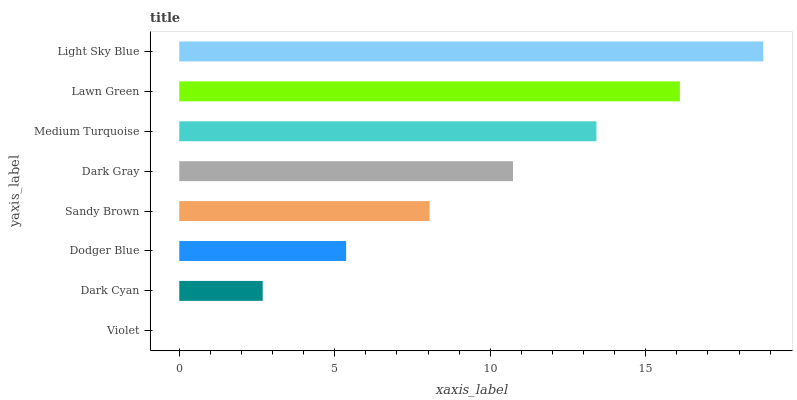Is Violet the minimum?
Answer yes or no. Yes. Is Light Sky Blue the maximum?
Answer yes or no. Yes. Is Dark Cyan the minimum?
Answer yes or no. No. Is Dark Cyan the maximum?
Answer yes or no. No. Is Dark Cyan greater than Violet?
Answer yes or no. Yes. Is Violet less than Dark Cyan?
Answer yes or no. Yes. Is Violet greater than Dark Cyan?
Answer yes or no. No. Is Dark Cyan less than Violet?
Answer yes or no. No. Is Dark Gray the high median?
Answer yes or no. Yes. Is Sandy Brown the low median?
Answer yes or no. Yes. Is Sandy Brown the high median?
Answer yes or no. No. Is Dark Gray the low median?
Answer yes or no. No. 